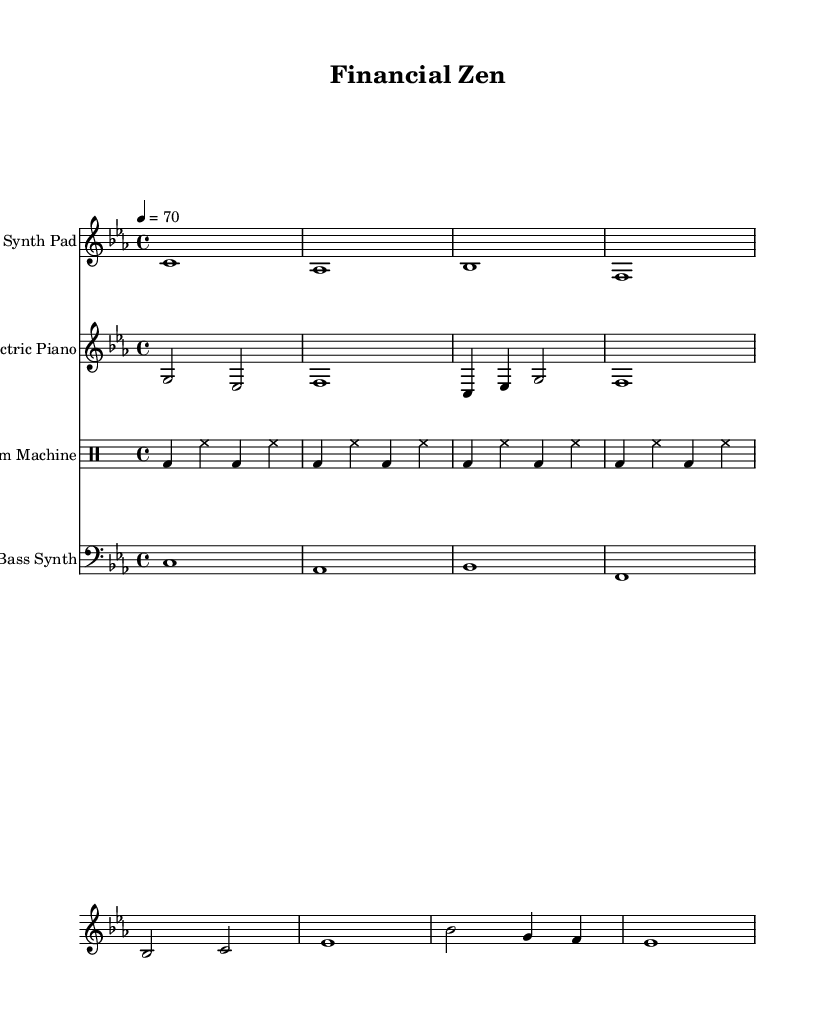What is the key signature of this music? The key signature is C minor, which has three flats (B♭, E♭, A♭). It can be identified by looking for the key signature notation at the beginning of the score, which shows the flats.
Answer: C minor What is the time signature of the piece? The time signature is 4/4, which means there are four beats in each measure and the quarter note receives one beat. This can be observed in the notation at the beginning, indicating how the measures are structured.
Answer: 4/4 What is the tempo marking of the music? The tempo marking is quarter note equals seventy beats per minute, as indicated at the start where it states "4 = 70." This tells performers how fast to play the music.
Answer: 70 How many measures does the Synth Pad part have? The Synth Pad part consists of four measures. This is determined by counting the individual measures separated by vertical lines in the notation.
Answer: 4 Which instruments are featured in this score? The score features a Synth Pad, Electric Piano, Drum Machine, and Bass Synth. These instruments are clearly labeled in the headers of their respective staves in the sheet music.
Answer: Synth Pad, Electric Piano, Drum Machine, Bass Synth What rhythm pattern does the Drum Machine use? The Drum Machine follows a repeating rhythm pattern comprised of bass drum and hi-hat in a consistent 4/4 pattern. This is evident from analyzing the drum notation, which shows the specific placement of notes representing the bass drum and hi-hat.
Answer: Bass drum and hi-hat pattern 